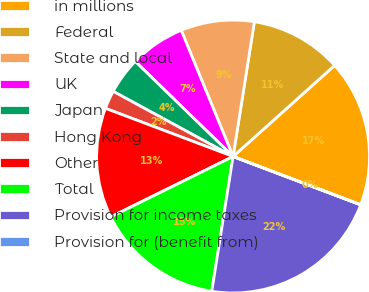<chart> <loc_0><loc_0><loc_500><loc_500><pie_chart><fcel>in millions<fcel>Federal<fcel>State and local<fcel>UK<fcel>Japan<fcel>Hong Kong<fcel>Other<fcel>Total<fcel>Provision for income taxes<fcel>Provision for (benefit from)<nl><fcel>17.39%<fcel>10.87%<fcel>8.7%<fcel>6.52%<fcel>4.35%<fcel>2.18%<fcel>13.04%<fcel>15.21%<fcel>21.73%<fcel>0.01%<nl></chart> 